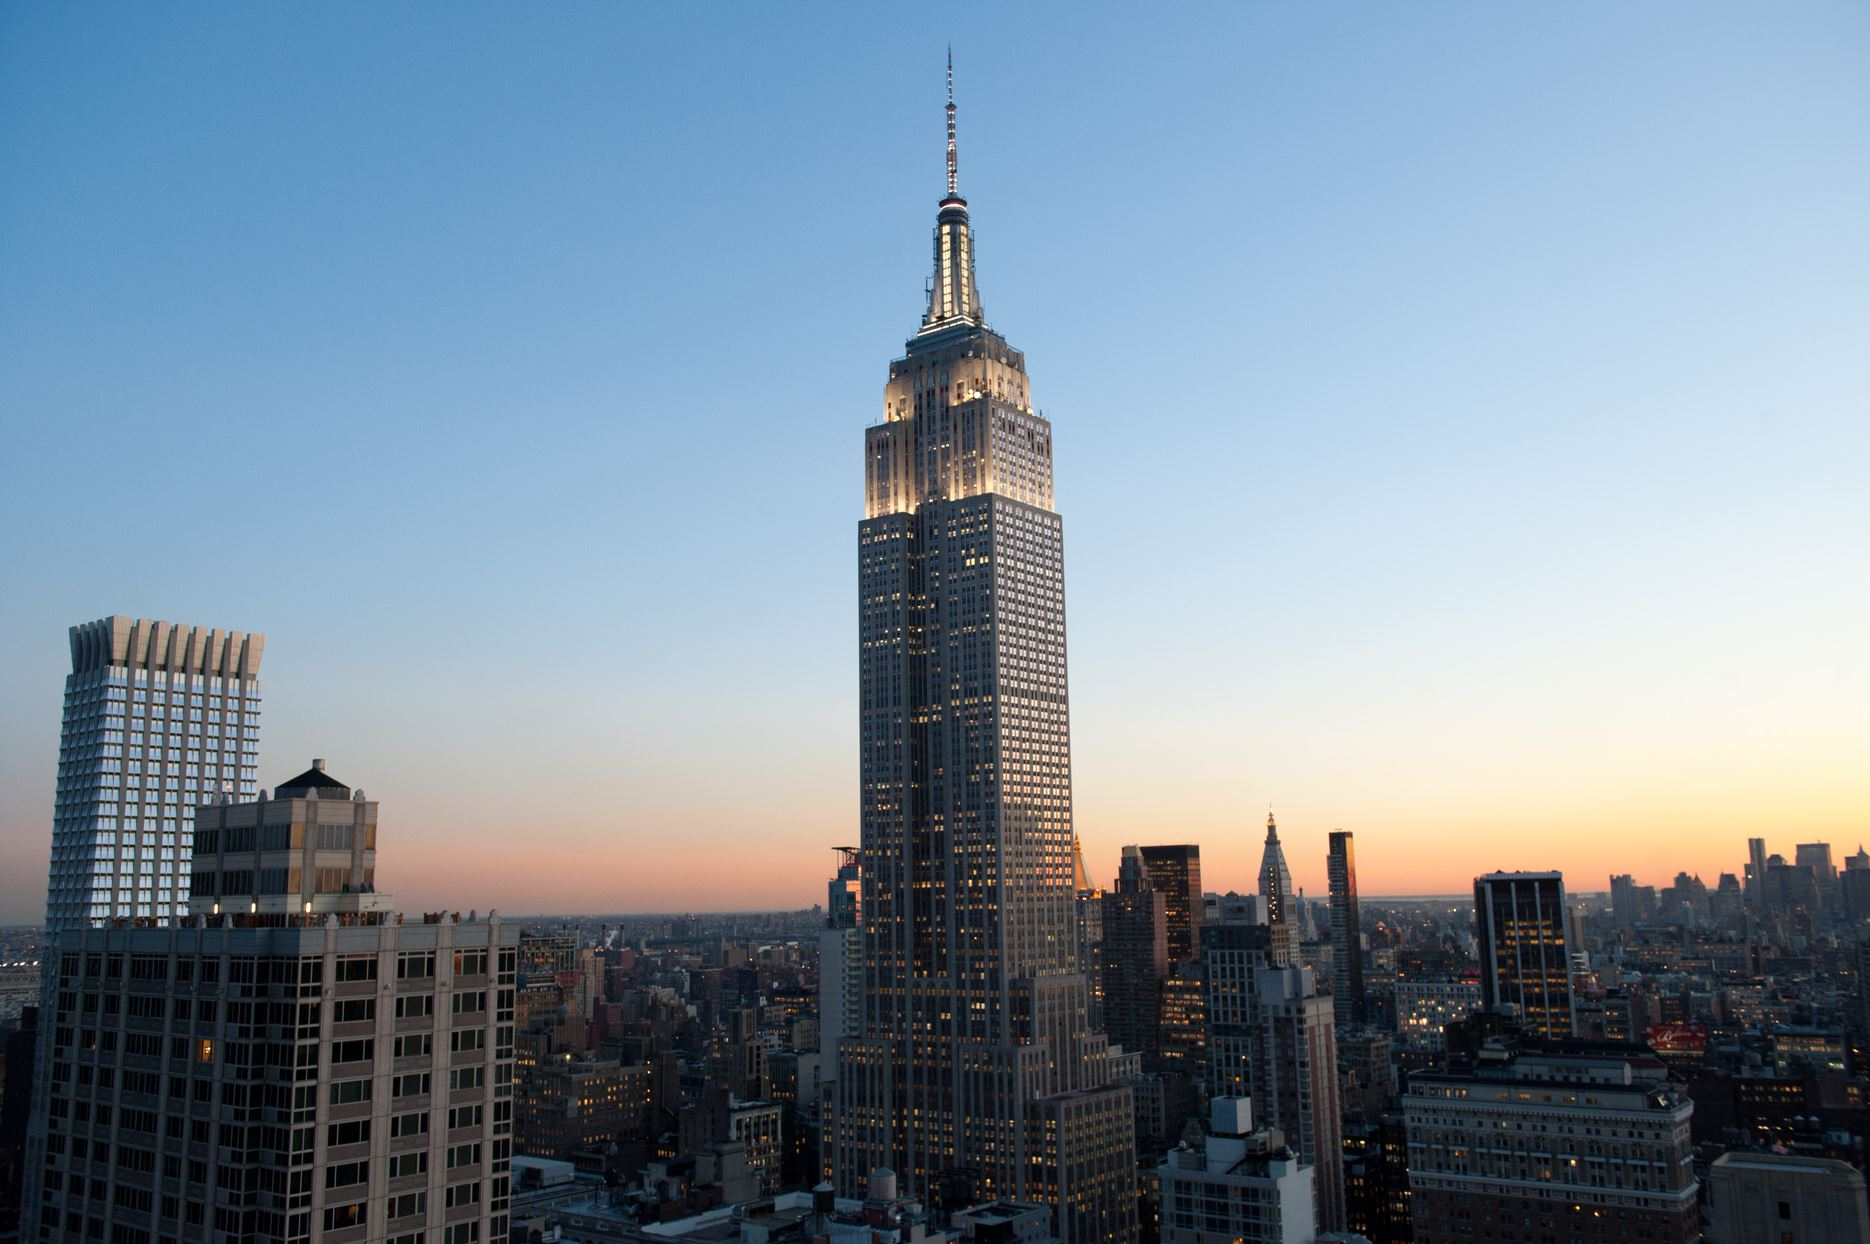Describe the atmosphere and feeling conveyed by this image. The image exudes a captivating and serene ambiance. The soft gradient in the sky, transitioning from orange to blue, indicates it is either sunset or sunrise. This natural light bathes the city in a warm and golden hue, creating a soothing contrast with the tall, imposing structures. The iconic Empire State Building stands majestically, illuminated and towering over the city, symbolizing resilience and grandeur. The scene evokes a sense of calmness yet is underscored by the energetic essence of New York City, making one feel at peace while being in the heart of a bustling metropolis. What might a tourist feel when witnessing this view? A tourist witnessing this view would likely be in awe of the breathtaking panorama. The sight of the iconic Empire State Building lit up against the cityscape, under the tranquil hues of the setting or rising sun, would be a memorable experience. The grandeur of the scene could evoke feelings of excitement and wonder, a reminder of why New York City is known as the city that never sleeps. This moment could inspire a sense of connection to the city's rich history and vibrant energy, mixed with a touch of nostalgia and appreciation for the beauty and complexity of urban life. 